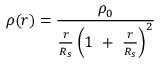<formula> <loc_0><loc_0><loc_500><loc_500>\rho ( r ) = { \frac { \rho _ { 0 } } { { \frac { r } { R _ { s } } } \left ( 1 + { \frac { r } { R _ { s } } } \right ) ^ { 2 } } }</formula> 